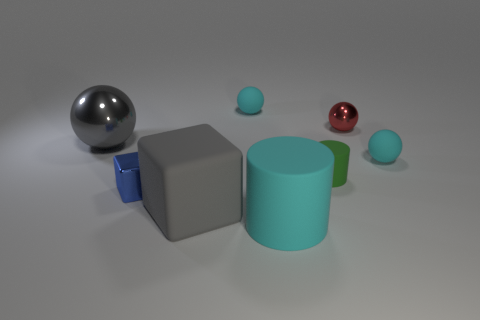What is the material of the large gray block?
Keep it short and to the point. Rubber. There is a shiny object in front of the object that is right of the metallic thing that is behind the large ball; how big is it?
Give a very brief answer. Small. What material is the large object that is the same color as the big ball?
Provide a short and direct response. Rubber. What number of metal things are brown objects or small spheres?
Give a very brief answer. 1. The cyan matte cylinder is what size?
Ensure brevity in your answer.  Large. How many things are either small blue blocks or tiny cyan matte spheres that are to the left of the large cyan cylinder?
Give a very brief answer. 2. How many other objects are the same color as the big cylinder?
Provide a succinct answer. 2. Is the size of the gray shiny thing the same as the shiny object that is right of the small block?
Ensure brevity in your answer.  No. Do the cyan matte thing behind the gray shiny object and the large gray rubber cube have the same size?
Keep it short and to the point. No. What number of other objects are there of the same material as the small cylinder?
Your answer should be compact. 4. 